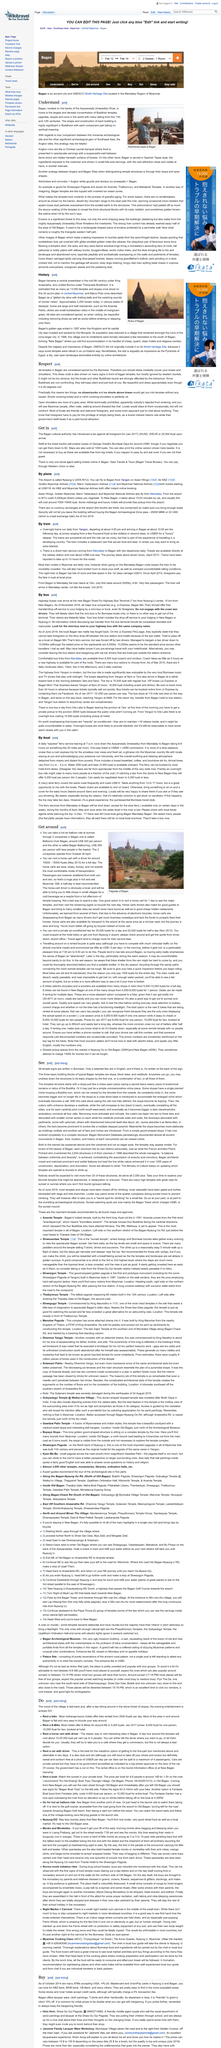List a handful of essential elements in this visual. In the mid 9th century, King Anawratha unified Burma and established it as a Theravada Buddhist kingdom. Bagan, located in Myanmar, is home to the largest and densest concentration of Buddhist temples in the world. The above picture portrays an abandoned pagoda at Bagan, which is a Buddhist temple or stupa located in the Bagan region of Myanmar. There are currently approximately 2,000 temples in Bagan, Myanmar, although many of them are in various states of disrepair. Bagan, a location known for its ancient temples and pagodas, can be found on the banks of the Ayeyarwady River. 